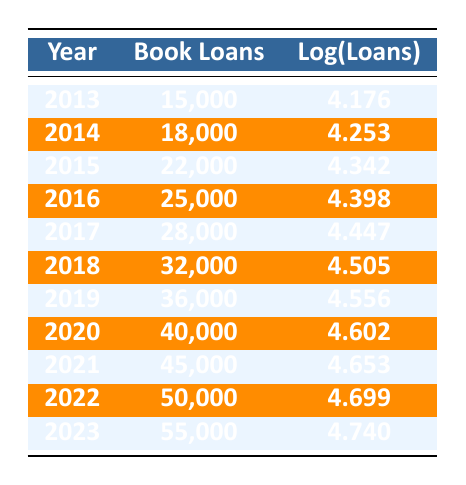What was the total number of book loans from 2013 to 2015? To find the total number of book loans from 2013 to 2015, we sum the loans for those years: 15000 (2013) + 18000 (2014) + 22000 (2015) = 55000.
Answer: 55000 What is the logarithmic value of book loans for 2022? According to the table, the log value for book loans in 2022 is stated directly: 4.699.
Answer: 4.699 Was there an increase in book loans from 2018 to 2019? In 2018, there were 32000 loans, and in 2019, there were 36000 loans. Since 36000 is greater than 32000, there was an increase.
Answer: Yes What was the average number of book loans from 2020 to 2023? To find the average, we first sum the loans from 2020 to 2023: 40000 + 45000 + 50000 + 55000 = 190000. Then, we divide by the number of years (4): 190000 / 4 = 47500.
Answer: 47500 In which year did the library experience the highest number of book loans? By examining the loans listed for each year, we see that 2023 has the highest number of loans at 55000.
Answer: 2023 What is the difference in the logarithmic values of loans between 2013 and 2021? We find the logarithmic values for both years: for 2013 it is 4.176 and for 2021 it is 4.653. We calculate the difference: 4.653 - 4.176 = 0.477.
Answer: 0.477 Did the book loans from 2016 to 2017 exceed the loans in 2015? The loans for 2016 are 25000 and for 2017 are 28000. Adding those gives: 25000 + 28000 = 53000, which does exceed the loans in 2015, which were 22000.
Answer: Yes What year had a log loan value closest to 4.5? Upon reviewing the logarithmic values, the closest to 4.5 is in 2018 with a log value of 4.505.
Answer: 2018 